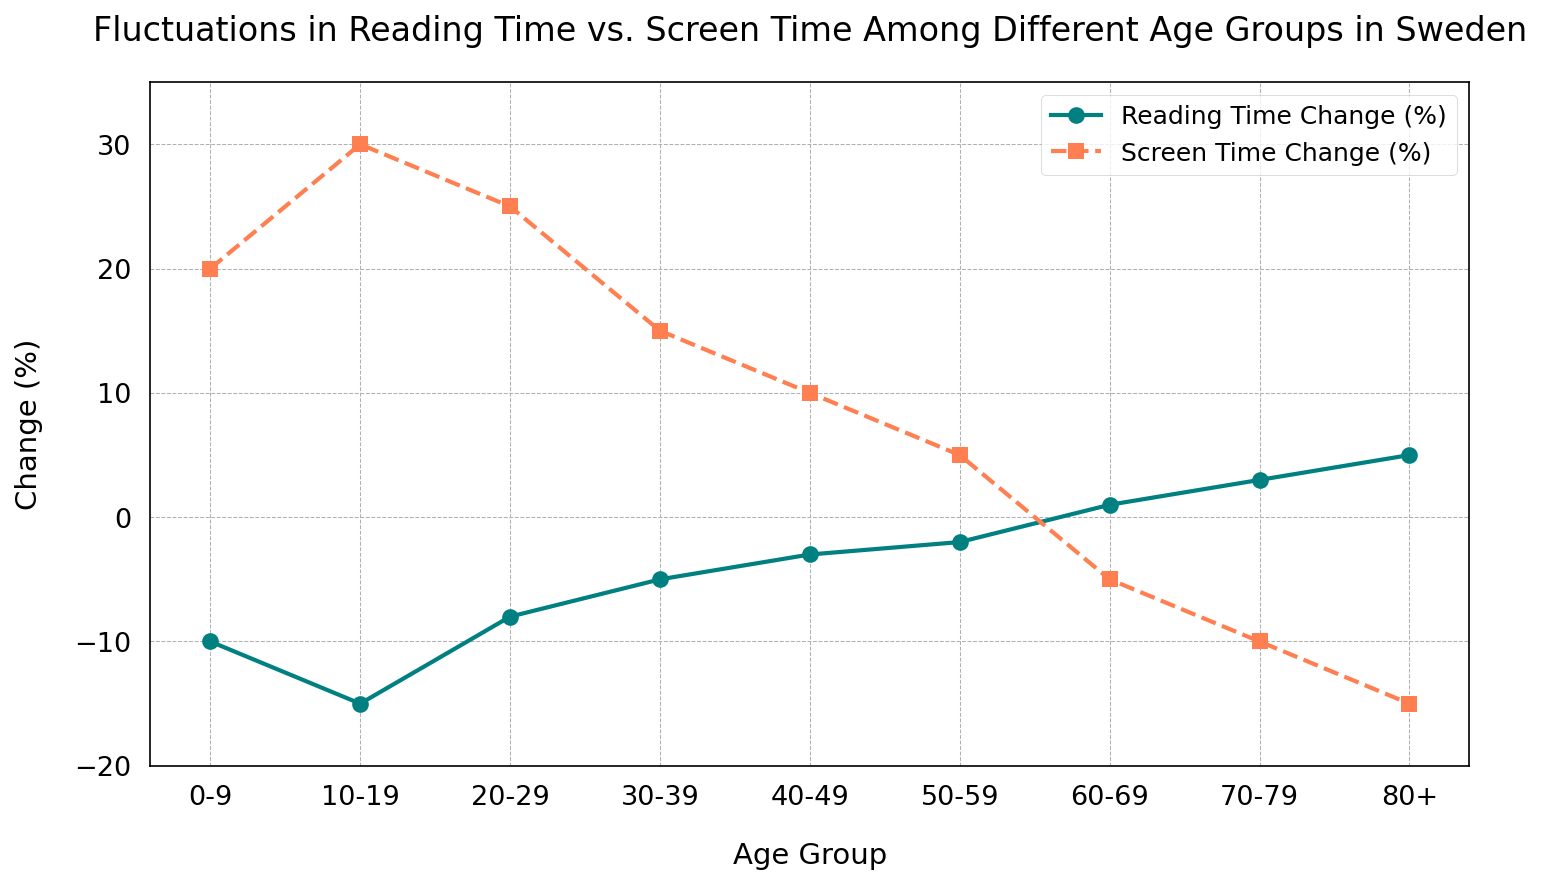What's the age group with the highest increase in reading time? The figure shows the "Reading Time Change (%)" for various age groups. The highest point on the line for reading time is at the "80+" age group, which has a change of 5%.
Answer: 80+ Which age group has the largest decrease in screen time? The figure illustrates the "Screen Time Change (%)" for different age groups. The most substantial dip in the screen time line occurs at the "80+" age group, with a change of -15%.
Answer: 80+ What's the difference in screen time change between the 0-9 and 80+ age groups? The screen time change for the "0-9" age group is 20%, and for the "80+" age group, it is -15%. The difference is calculated as 20% - (-15%) = 35%.
Answer: 35% Comparing the 10-19 and 70-79 age groups, which one has a greater increase in reading time? The reading time change for the "10-19" age group is -15%, while for the "70-79" age group, it is 3%. Since 3% is greater than -15%, the "70-79" age group has a greater increase.
Answer: 70-79 What is the total change in reading time for the 30-39 and 40-49 age groups combined? The reading time change for the "30-39" age group is -5%, and for the "40-49" age group, it is -3%. The total change is -5% + (-3%) = -8%.
Answer: -8% How much more did reading time change for the 80+ age group compared to the 20-29 age group? The reading time change for the "80+" age group is 5%, and for the "20-29" age group, it is -8%. The difference is calculated as 5% - (-8%) = 13%.
Answer: 13% Which age group saw an increase in both reading time and screen time? The figure shows reading time and screen time changes for different age groups. The "0-9" age group is the only one that shows an increase in both (Reading Time Change = -10%, Screen Time Change = 20%).
Answer: No age group 